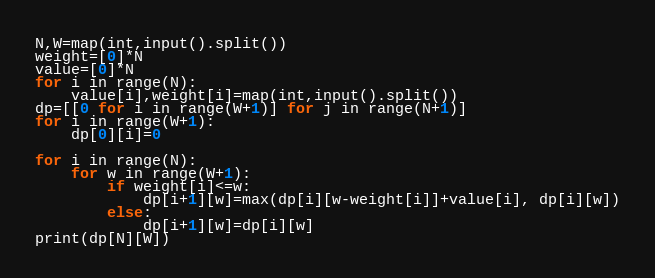Convert code to text. <code><loc_0><loc_0><loc_500><loc_500><_Python_>N,W=map(int,input().split())
weight=[0]*N
value=[0]*N
for i in range(N):
    value[i],weight[i]=map(int,input().split())
dp=[[0 for i in range(W+1)] for j in range(N+1)]
for i in range(W+1):
    dp[0][i]=0

for i in range(N):
    for w in range(W+1):
        if weight[i]<=w:
            dp[i+1][w]=max(dp[i][w-weight[i]]+value[i], dp[i][w])
        else:
            dp[i+1][w]=dp[i][w]
print(dp[N][W])
</code> 